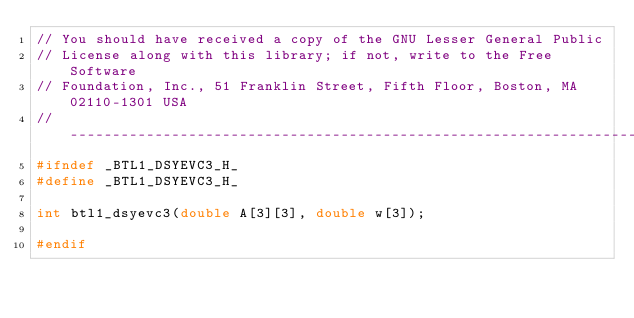<code> <loc_0><loc_0><loc_500><loc_500><_C_>// You should have received a copy of the GNU Lesser General Public
// License along with this library; if not, write to the Free Software
// Foundation, Inc., 51 Franklin Street, Fifth Floor, Boston, MA 02110-1301 USA
// ----------------------------------------------------------------------------
#ifndef _BTL1_DSYEVC3_H_
#define _BTL1_DSYEVC3_H_

int btl1_dsyevc3(double A[3][3], double w[3]);

#endif
</code> 